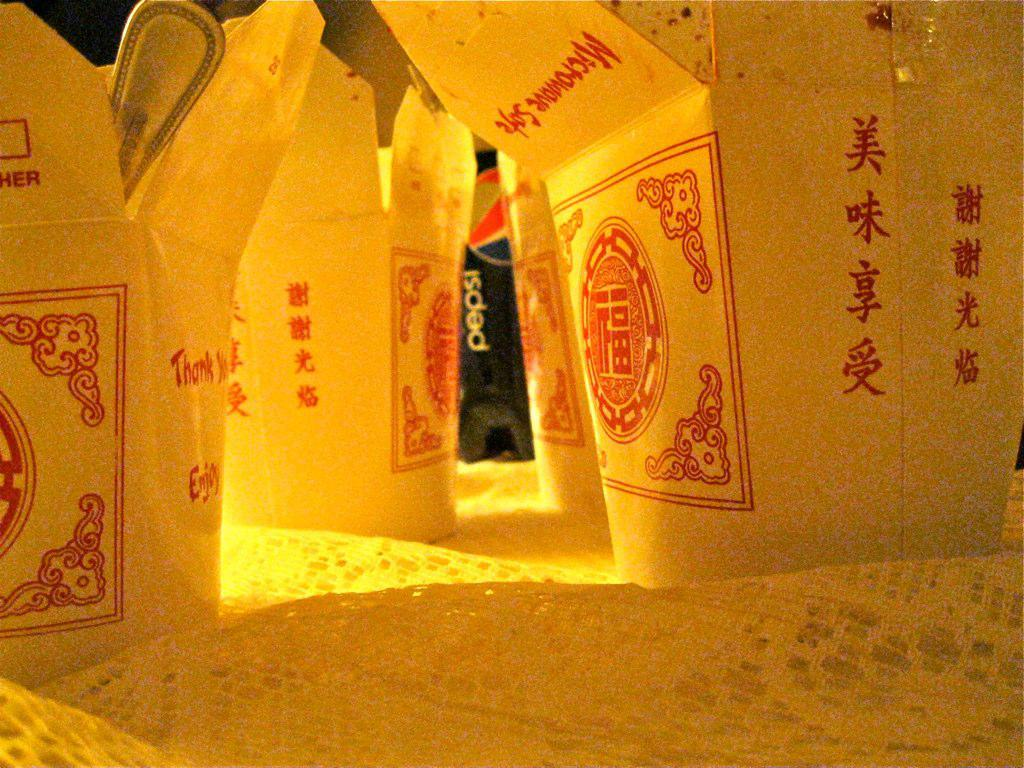<image>
Give a short and clear explanation of the subsequent image. A bottle of Pepsi is behind several Chinese food take out containers. 